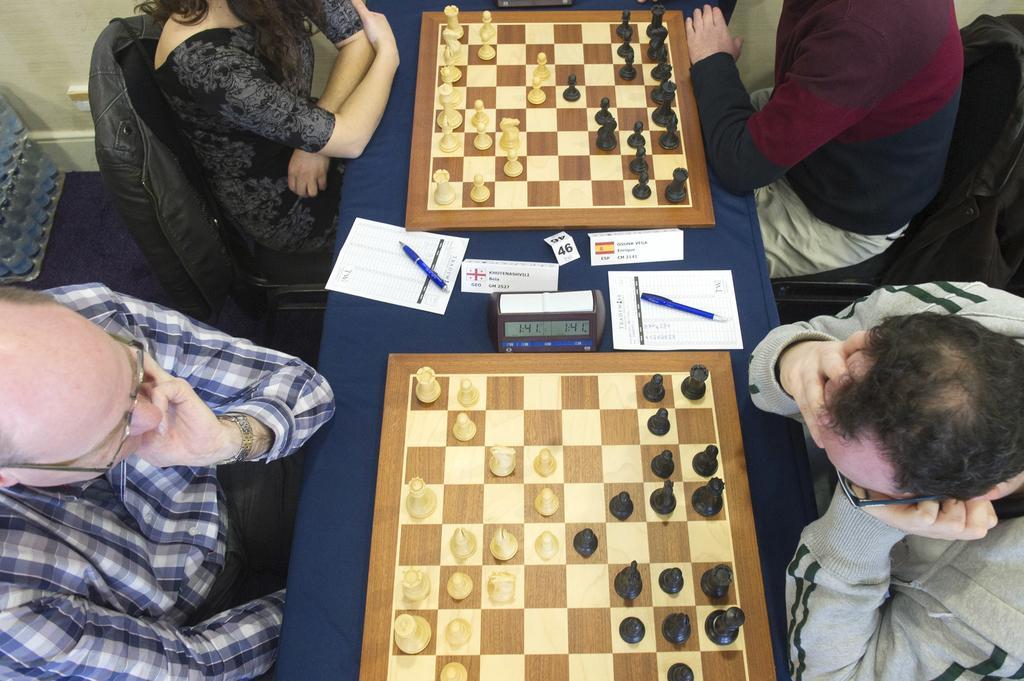How would you summarize this image in a sentence or two? In this image there are group of people sitting in chair and playing the chess game in a table there are pen , paper, timer, chessboard , chess coins and in back ground there are water bottles. 